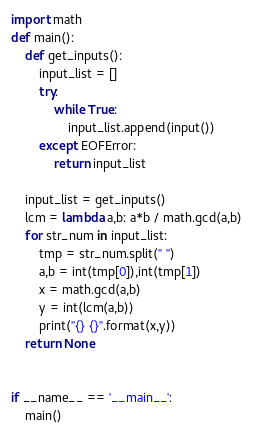<code> <loc_0><loc_0><loc_500><loc_500><_Python_>import math
def main():
    def get_inputs():
        input_list = []
        try:
            while True:
                input_list.append(input())
        except EOFError:
            return input_list

    input_list = get_inputs()
    lcm = lambda a,b: a*b / math.gcd(a,b)
    for str_num in input_list:
        tmp = str_num.split(" ")
        a,b = int(tmp[0]),int(tmp[1])
        x = math.gcd(a,b)
        y = int(lcm(a,b))
        print("{} {}".format(x,y))
    return None


if __name__ == '__main__':
    main()</code> 